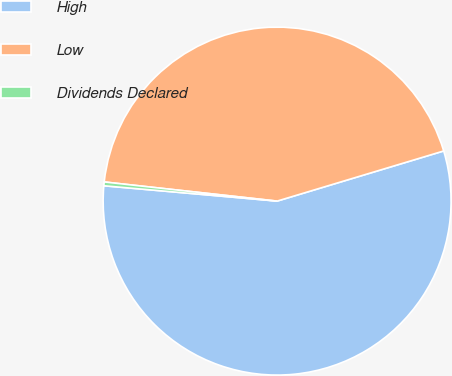Convert chart to OTSL. <chart><loc_0><loc_0><loc_500><loc_500><pie_chart><fcel>High<fcel>Low<fcel>Dividends Declared<nl><fcel>56.06%<fcel>43.59%<fcel>0.35%<nl></chart> 